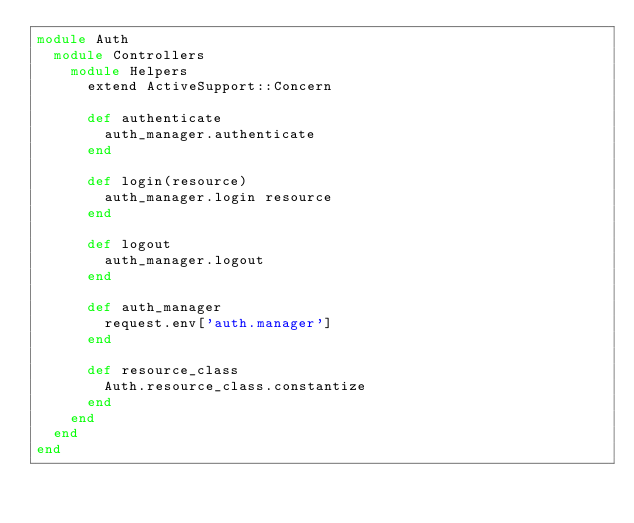<code> <loc_0><loc_0><loc_500><loc_500><_Ruby_>module Auth
  module Controllers
    module Helpers
      extend ActiveSupport::Concern

      def authenticate
        auth_manager.authenticate
      end

      def login(resource)
        auth_manager.login resource
      end

      def logout
        auth_manager.logout
      end

      def auth_manager
        request.env['auth.manager']
      end

      def resource_class
        Auth.resource_class.constantize
      end
    end
  end
end
</code> 